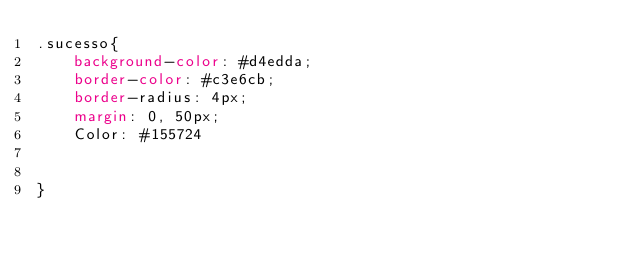<code> <loc_0><loc_0><loc_500><loc_500><_CSS_>.sucesso{
    background-color: #d4edda;
    border-color: #c3e6cb;
    border-radius: 4px;
    margin: 0, 50px;
    Color: #155724  


}</code> 